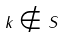Convert formula to latex. <formula><loc_0><loc_0><loc_500><loc_500>k \notin S</formula> 